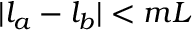<formula> <loc_0><loc_0><loc_500><loc_500>| l _ { a } - l _ { b } | < m L</formula> 